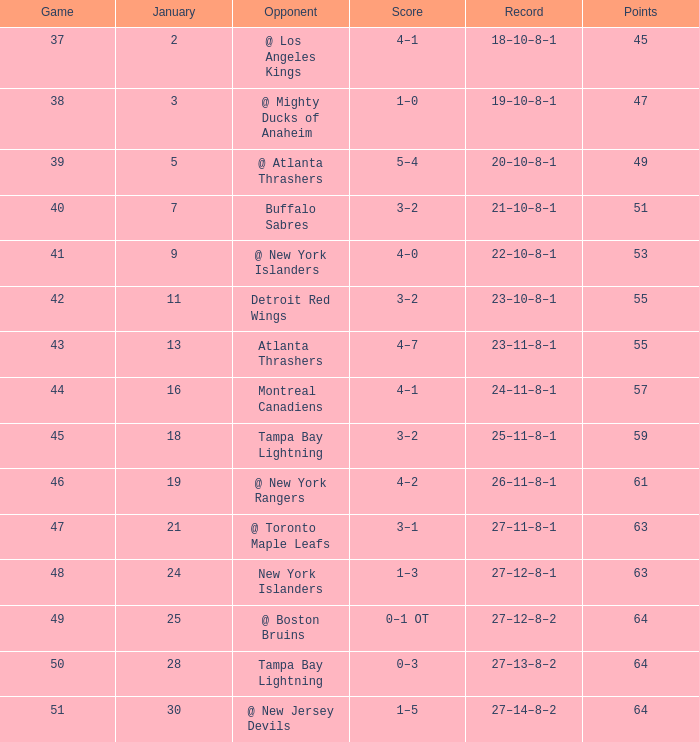Give me the full table as a dictionary. {'header': ['Game', 'January', 'Opponent', 'Score', 'Record', 'Points'], 'rows': [['37', '2', '@ Los Angeles Kings', '4–1', '18–10–8–1', '45'], ['38', '3', '@ Mighty Ducks of Anaheim', '1–0', '19–10–8–1', '47'], ['39', '5', '@ Atlanta Thrashers', '5–4', '20–10–8–1', '49'], ['40', '7', 'Buffalo Sabres', '3–2', '21–10–8–1', '51'], ['41', '9', '@ New York Islanders', '4–0', '22–10–8–1', '53'], ['42', '11', 'Detroit Red Wings', '3–2', '23–10–8–1', '55'], ['43', '13', 'Atlanta Thrashers', '4–7', '23–11–8–1', '55'], ['44', '16', 'Montreal Canadiens', '4–1', '24–11–8–1', '57'], ['45', '18', 'Tampa Bay Lightning', '3–2', '25–11–8–1', '59'], ['46', '19', '@ New York Rangers', '4–2', '26–11–8–1', '61'], ['47', '21', '@ Toronto Maple Leafs', '3–1', '27–11–8–1', '63'], ['48', '24', 'New York Islanders', '1–3', '27–12–8–1', '63'], ['49', '25', '@ Boston Bruins', '0–1 OT', '27–12–8–2', '64'], ['50', '28', 'Tampa Bay Lightning', '0–3', '27–13–8–2', '64'], ['51', '30', '@ New Jersey Devils', '1–5', '27–14–8–2', '64']]} Which Points have a Score of 4–1, and a Record of 18–10–8–1, and a January larger than 2? None. 